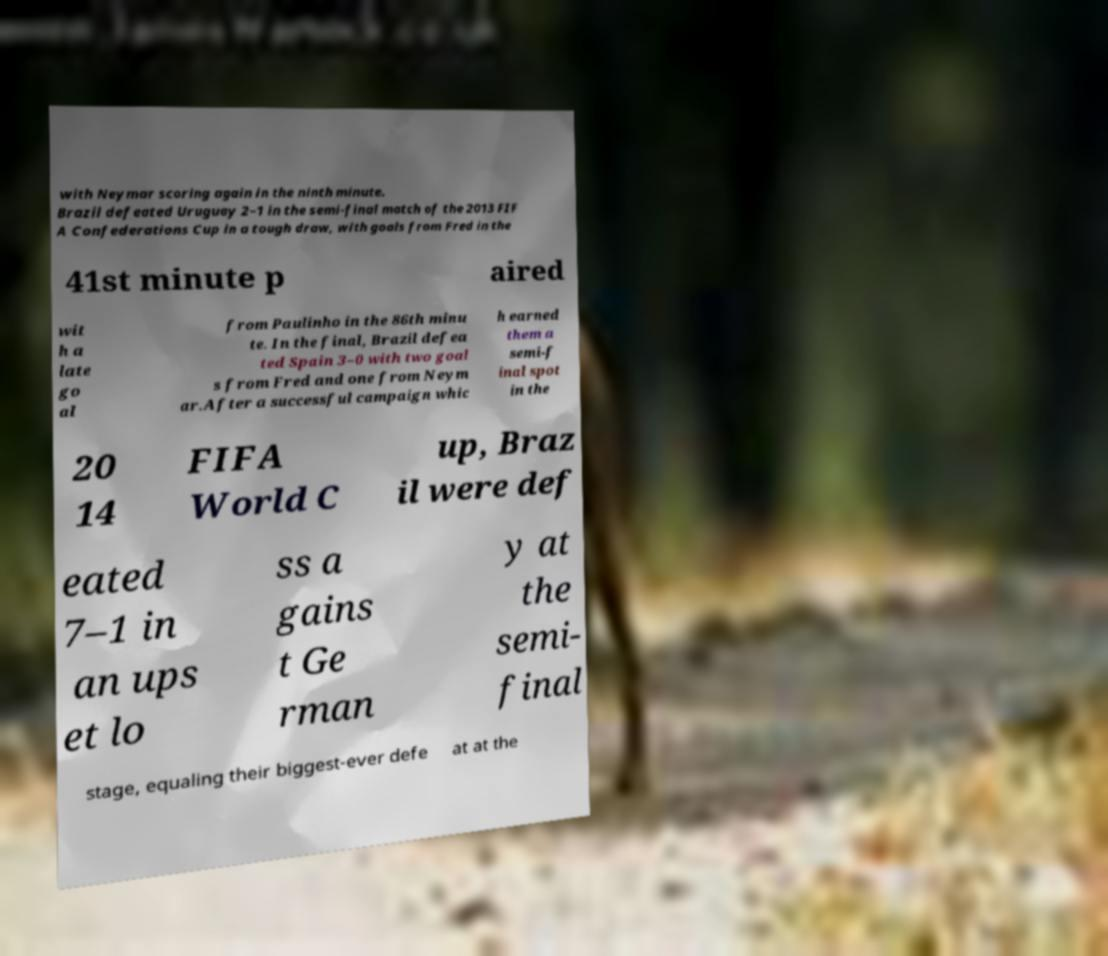Can you read and provide the text displayed in the image?This photo seems to have some interesting text. Can you extract and type it out for me? with Neymar scoring again in the ninth minute. Brazil defeated Uruguay 2–1 in the semi-final match of the 2013 FIF A Confederations Cup in a tough draw, with goals from Fred in the 41st minute p aired wit h a late go al from Paulinho in the 86th minu te. In the final, Brazil defea ted Spain 3–0 with two goal s from Fred and one from Neym ar.After a successful campaign whic h earned them a semi-f inal spot in the 20 14 FIFA World C up, Braz il were def eated 7–1 in an ups et lo ss a gains t Ge rman y at the semi- final stage, equaling their biggest-ever defe at at the 